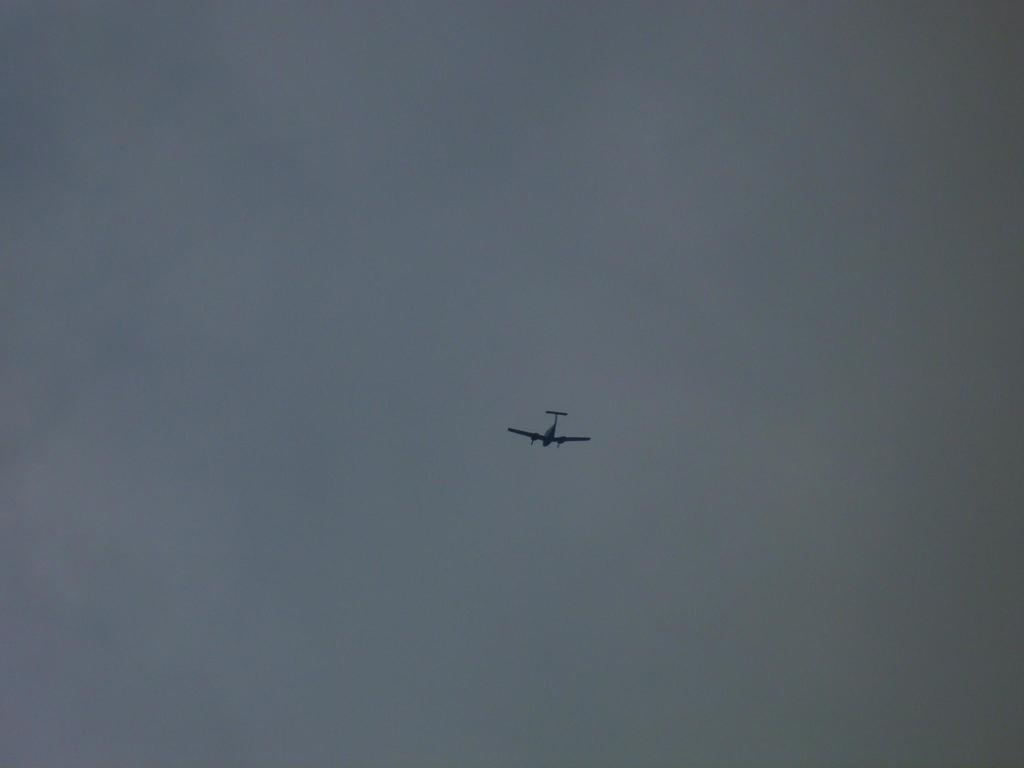Describe this image in one or two sentences. In the foreground of this image, there is a plane in the air. In the background, there is the sky. 